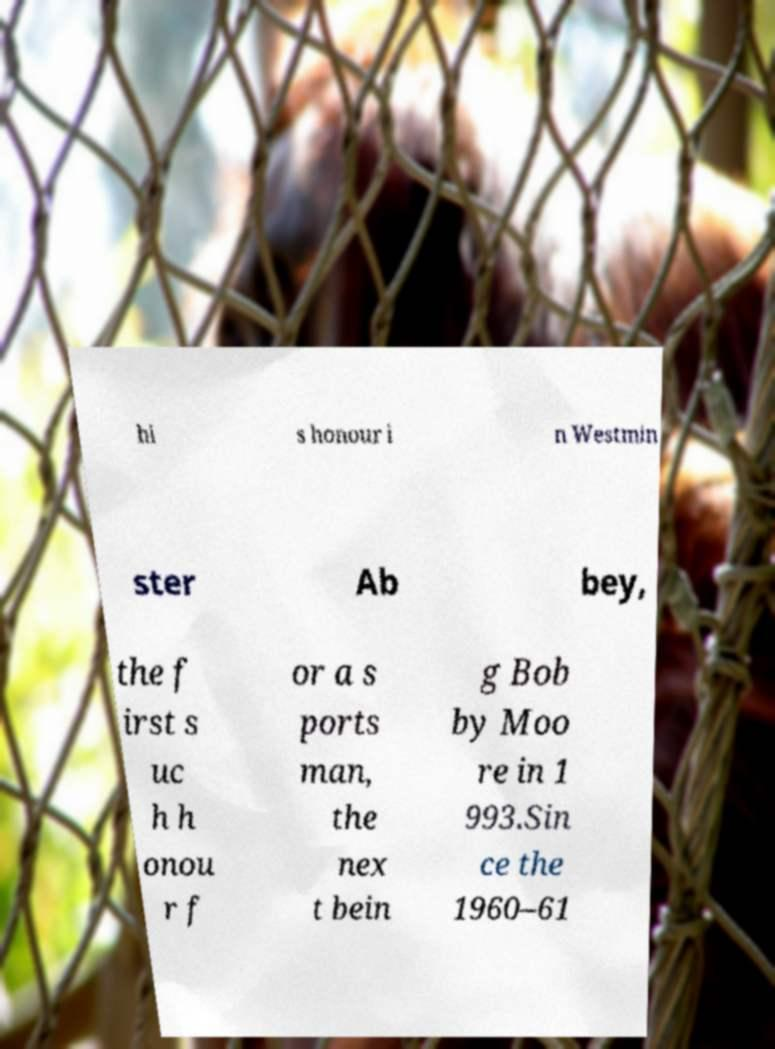What messages or text are displayed in this image? I need them in a readable, typed format. hi s honour i n Westmin ster Ab bey, the f irst s uc h h onou r f or a s ports man, the nex t bein g Bob by Moo re in 1 993.Sin ce the 1960–61 